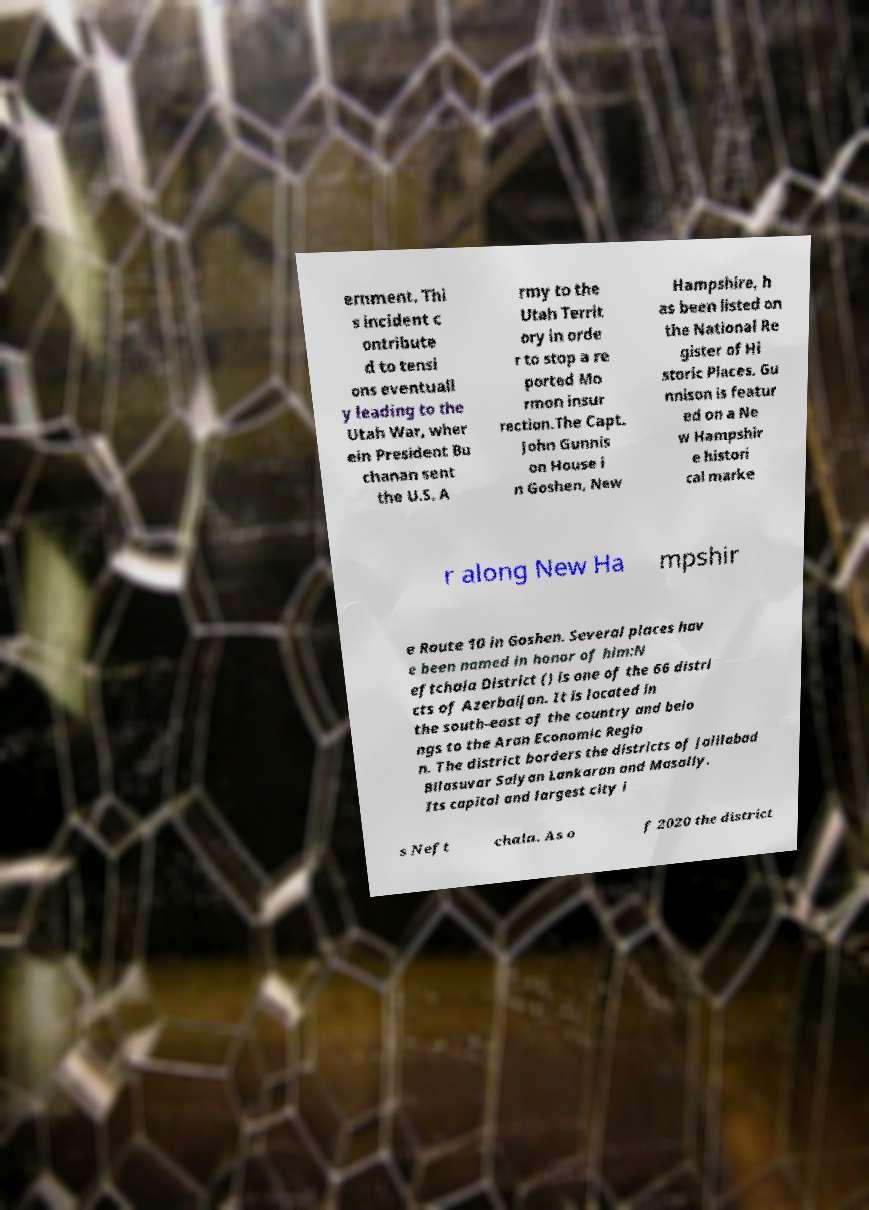What messages or text are displayed in this image? I need them in a readable, typed format. ernment. Thi s incident c ontribute d to tensi ons eventuall y leading to the Utah War, wher ein President Bu chanan sent the U.S. A rmy to the Utah Territ ory in orde r to stop a re ported Mo rmon insur rection.The Capt. John Gunnis on House i n Goshen, New Hampshire, h as been listed on the National Re gister of Hi storic Places. Gu nnison is featur ed on a Ne w Hampshir e histori cal marke r along New Ha mpshir e Route 10 in Goshen. Several places hav e been named in honor of him:N eftchala District () is one of the 66 distri cts of Azerbaijan. It is located in the south-east of the country and belo ngs to the Aran Economic Regio n. The district borders the districts of Jalilabad Bilasuvar Salyan Lankaran and Masally. Its capital and largest city i s Neft chala. As o f 2020 the district 